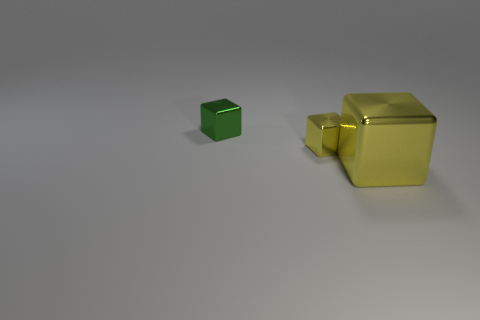There is a object that is on the left side of the small thing that is to the right of the small green cube; are there any tiny blocks that are to the left of it?
Provide a short and direct response. No. Is the number of blue metal things less than the number of big yellow objects?
Make the answer very short. Yes. Do the tiny yellow shiny object that is on the left side of the big object and the big yellow thing have the same shape?
Keep it short and to the point. Yes. Is there a big purple matte object?
Ensure brevity in your answer.  No. There is a small thing that is in front of the small metal thing that is behind the small metallic thing right of the green object; what is its color?
Your answer should be compact. Yellow. Are there the same number of small green objects in front of the large yellow block and small yellow metal cubes on the left side of the green shiny block?
Ensure brevity in your answer.  Yes. There is another shiny thing that is the same size as the green thing; what is its shape?
Ensure brevity in your answer.  Cube. Is there a large metal object that has the same color as the large block?
Your answer should be very brief. No. There is a small shiny object that is right of the small green metallic block; what shape is it?
Offer a terse response. Cube. There is another tiny object that is made of the same material as the small yellow object; what color is it?
Keep it short and to the point. Green. 